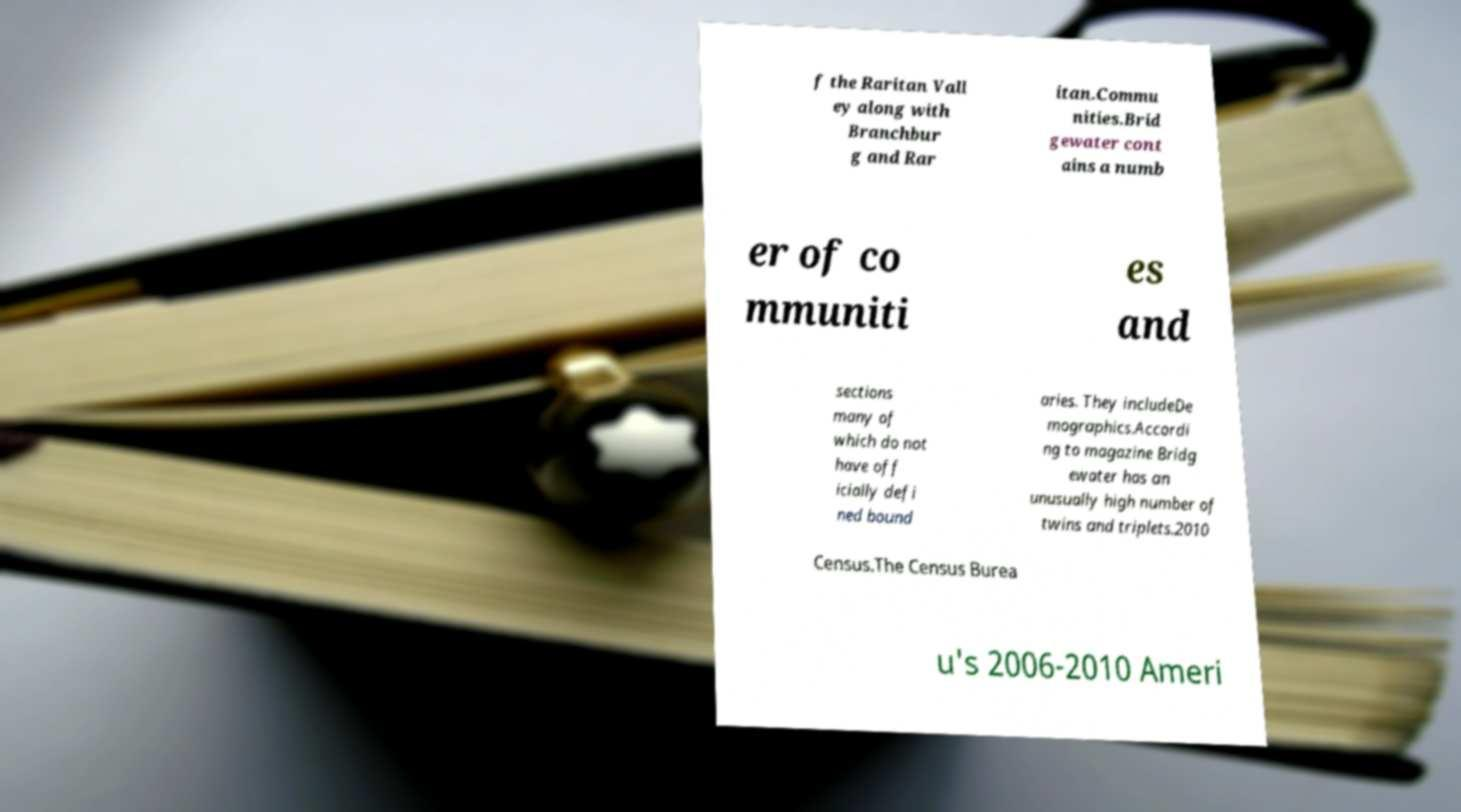For documentation purposes, I need the text within this image transcribed. Could you provide that? f the Raritan Vall ey along with Branchbur g and Rar itan.Commu nities.Brid gewater cont ains a numb er of co mmuniti es and sections many of which do not have off icially defi ned bound aries. They includeDe mographics.Accordi ng to magazine Bridg ewater has an unusually high number of twins and triplets.2010 Census.The Census Burea u's 2006-2010 Ameri 